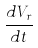Convert formula to latex. <formula><loc_0><loc_0><loc_500><loc_500>\frac { d V _ { r } } { d t }</formula> 